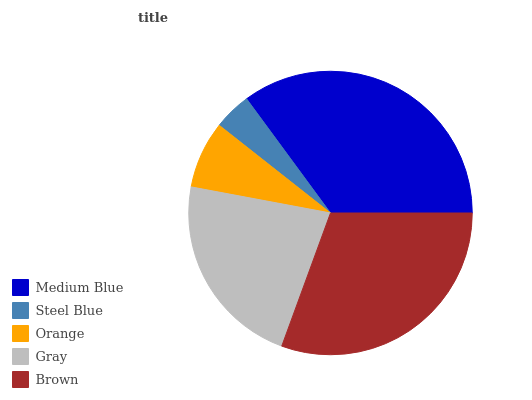Is Steel Blue the minimum?
Answer yes or no. Yes. Is Medium Blue the maximum?
Answer yes or no. Yes. Is Orange the minimum?
Answer yes or no. No. Is Orange the maximum?
Answer yes or no. No. Is Orange greater than Steel Blue?
Answer yes or no. Yes. Is Steel Blue less than Orange?
Answer yes or no. Yes. Is Steel Blue greater than Orange?
Answer yes or no. No. Is Orange less than Steel Blue?
Answer yes or no. No. Is Gray the high median?
Answer yes or no. Yes. Is Gray the low median?
Answer yes or no. Yes. Is Medium Blue the high median?
Answer yes or no. No. Is Medium Blue the low median?
Answer yes or no. No. 